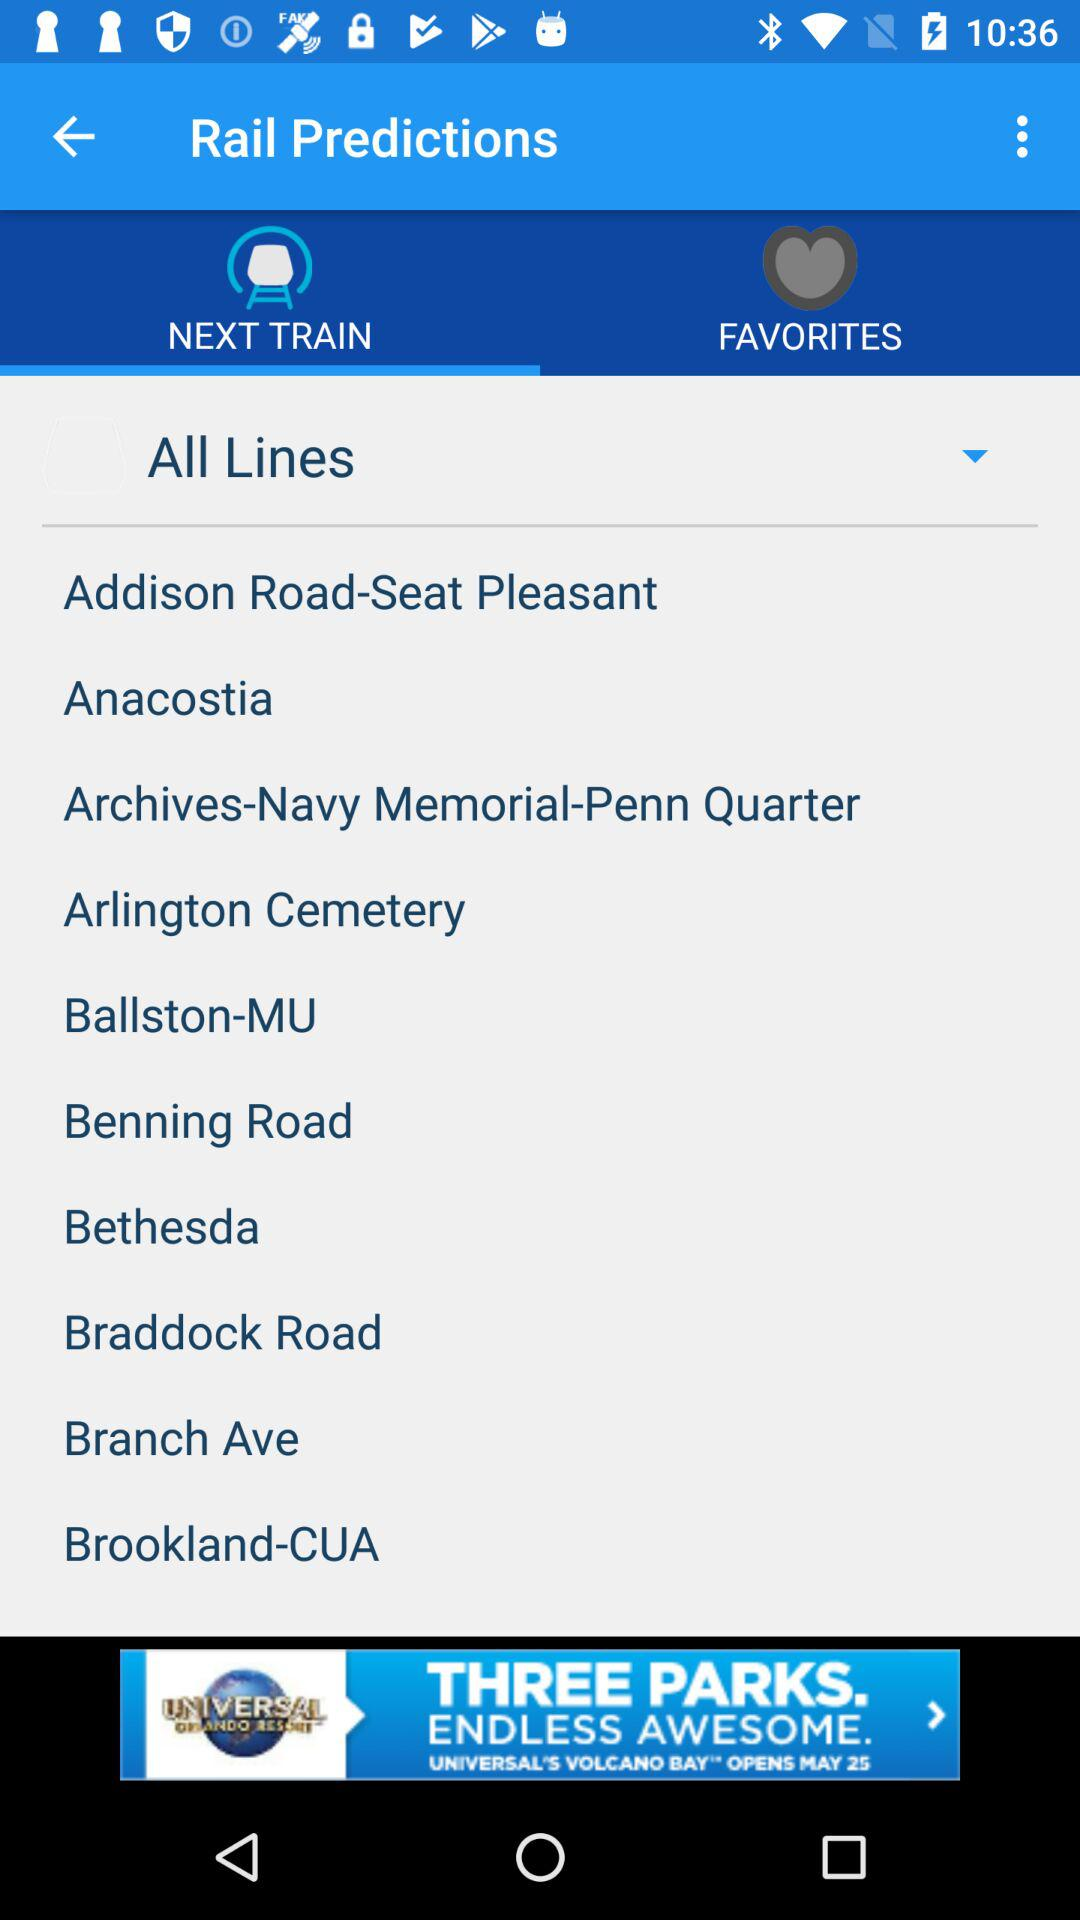Which tab am I on? You are on "NEXT TRAIN" tab. 